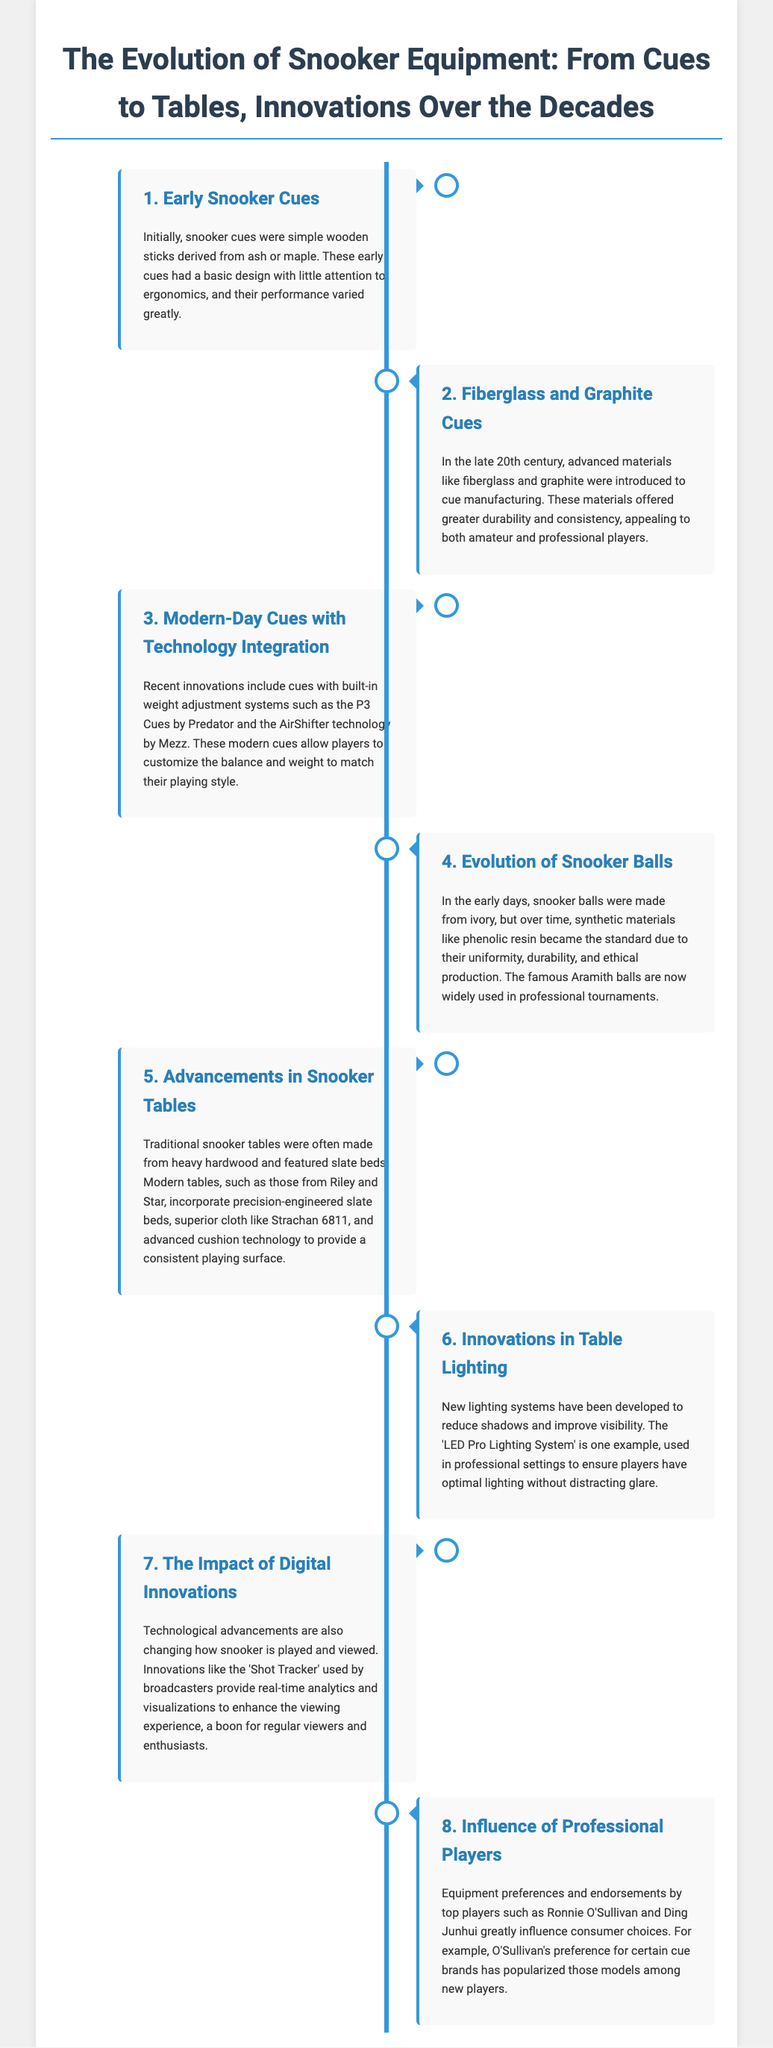What were early snooker cues made from? The document states that early snooker cues were primarily made from ash or maple.
Answer: ash or maple When did advanced materials like fiberglass and graphite begin to be used? According to the document, fiberglass and graphite cues were introduced in the late 20th century.
Answer: late 20th century What is a significant feature of modern-day cues mentioned in the document? The document highlights that modern-day cues have built-in weight adjustment systems.
Answer: weight adjustment systems What material replaced ivory for snooker balls? The document mentions that synthetic materials like phenolic resin became the standard due to their uniformity and durability.
Answer: phenolic resin Which table brands are noted for their advancements in snooker tables? The document mentions that tables from Riley and Star include precision-engineered features and superior cloth.
Answer: Riley and Star How have digital innovations impacted snooker? The document notes that innovations like the 'Shot Tracker' provide real-time analytics and visualizations.
Answer: real-time analytics Which technology improves visibility in snooker? The document refers to the 'LED Pro Lighting System' as a new lighting system improving visibility.
Answer: LED Pro Lighting System What player is mentioned as influencing equipment choices? The document cites Ronnie O'Sullivan as a significant influencer regarding cue brands.
Answer: Ronnie O'Sullivan What synthetic material standard is used for snooker balls today? The document states that Aramith balls, made from synthetic materials, are widely used in professional tournaments.
Answer: Aramith balls 